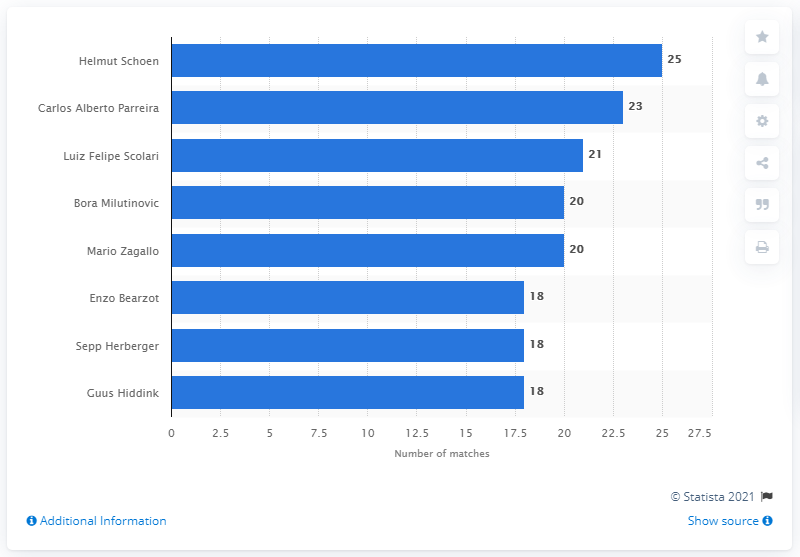Outline some significant characteristics in this image. Helmut Schoen managed the West German national team for four consecutive tournaments between 1966 and 1978. During his tenure as manager of the West German national team between 1966 and 1978, Helmut Schoen oversaw a total of 25 matches. 